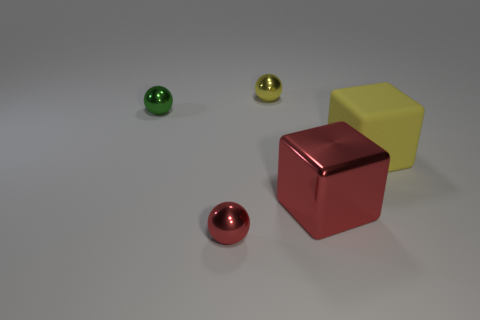Are there any other things that have the same material as the green thing?
Keep it short and to the point. Yes. Is the number of shiny cubes that are to the left of the small red sphere greater than the number of large rubber spheres?
Your response must be concise. No. There is a large object that is behind the large block to the left of the yellow rubber object; are there any rubber objects behind it?
Ensure brevity in your answer.  No. There is a red ball; are there any small green balls to the left of it?
Give a very brief answer. Yes. How many tiny metal things are the same color as the big metal thing?
Your response must be concise. 1. The red ball that is the same material as the yellow sphere is what size?
Give a very brief answer. Small. There is a metal ball that is in front of the small green metallic thing that is left of the large cube in front of the big matte thing; what size is it?
Provide a succinct answer. Small. What size is the metallic sphere that is behind the tiny green shiny object?
Your answer should be very brief. Small. What number of blue things are rubber cubes or spheres?
Provide a short and direct response. 0. Are there any yellow blocks that have the same size as the yellow matte thing?
Make the answer very short. No. 